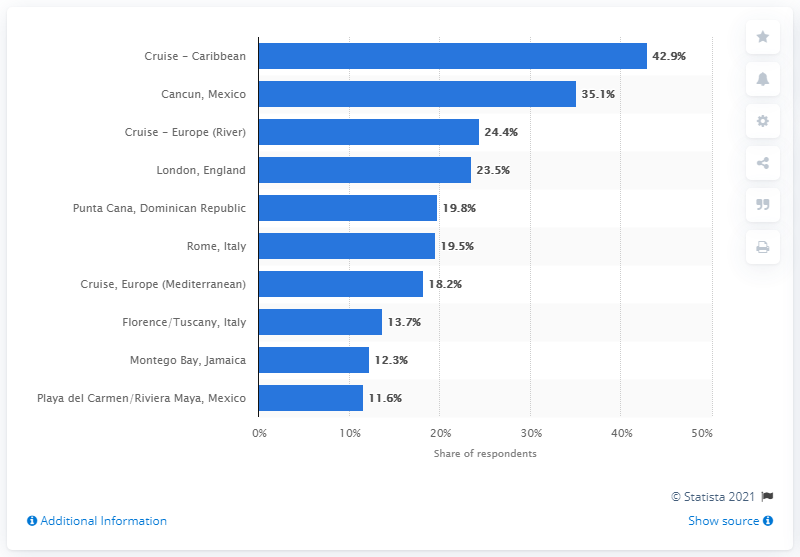Draw attention to some important aspects in this diagram. In 2016, the most popular international destination for U.S. travelers was the Caribbean by cruise. 